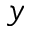<formula> <loc_0><loc_0><loc_500><loc_500>y</formula> 